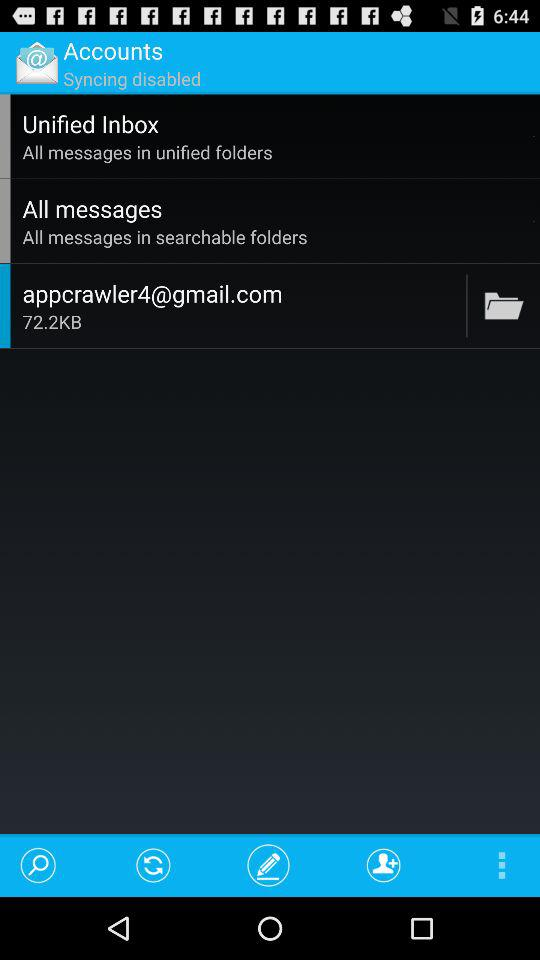What is the email address? The email address is appcrawler4@gmail.com. 